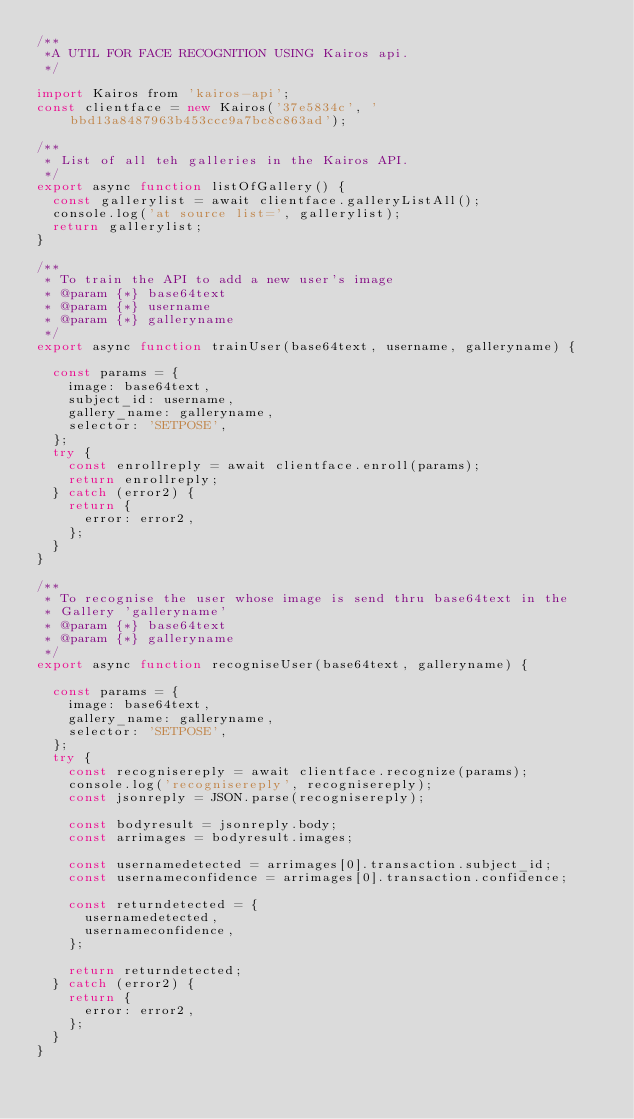<code> <loc_0><loc_0><loc_500><loc_500><_JavaScript_>/**
 *A UTIL FOR FACE RECOGNITION USING Kairos api.
 */

import Kairos from 'kairos-api';
const clientface = new Kairos('37e5834c', 'bbd13a8487963b453ccc9a7bc8c863ad');

/**
 * List of all teh galleries in the Kairos API.
 */
export async function listOfGallery() {
  const gallerylist = await clientface.galleryListAll();
  console.log('at source list=', gallerylist);
  return gallerylist;
}

/**
 * To train the API to add a new user's image
 * @param {*} base64text
 * @param {*} username
 * @param {*} galleryname
 */
export async function trainUser(base64text, username, galleryname) {

  const params = {
    image: base64text,
    subject_id: username,
    gallery_name: galleryname,
    selector: 'SETPOSE',
  };
  try {
    const enrollreply = await clientface.enroll(params);
    return enrollreply;
  } catch (error2) {
    return {
      error: error2,
    };
  }
}

/**
 * To recognise the user whose image is send thru base64text in the
 * Gallery 'galleryname'
 * @param {*} base64text
 * @param {*} galleryname
 */
export async function recogniseUser(base64text, galleryname) {

  const params = {
    image: base64text,
    gallery_name: galleryname,
    selector: 'SETPOSE',
  };
  try {
    const recognisereply = await clientface.recognize(params);
    console.log('recognisereply', recognisereply);
    const jsonreply = JSON.parse(recognisereply);

    const bodyresult = jsonreply.body;
    const arrimages = bodyresult.images;

    const usernamedetected = arrimages[0].transaction.subject_id;
    const usernameconfidence = arrimages[0].transaction.confidence;

    const returndetected = {
      usernamedetected,
      usernameconfidence,
    };

    return returndetected;
  } catch (error2) {
    return {
      error: error2,
    };
  }
}
</code> 